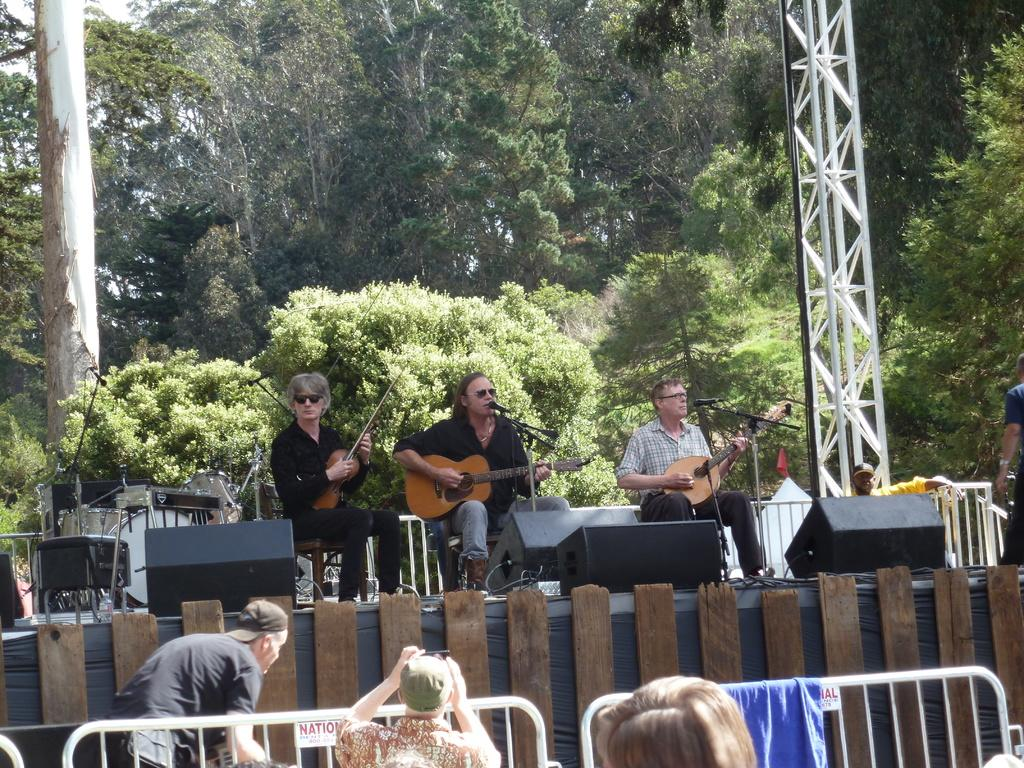What is the main activity being performed by the group of people in the image? The people in the image are playing the guitar. How are the people positioned in the image? The people are sitting on the floor. What equipment is present in the image to amplify sound? There is a microphone in the image. What can be seen in the background of the image? There are trees in the background of the image. How many times do the people in the image drop their guitars? There is no indication in the image that the people drop their guitars, so it cannot be determined. What type of form is being filled out by the people in the image? There is no form present in the image; the people are playing the guitar. 